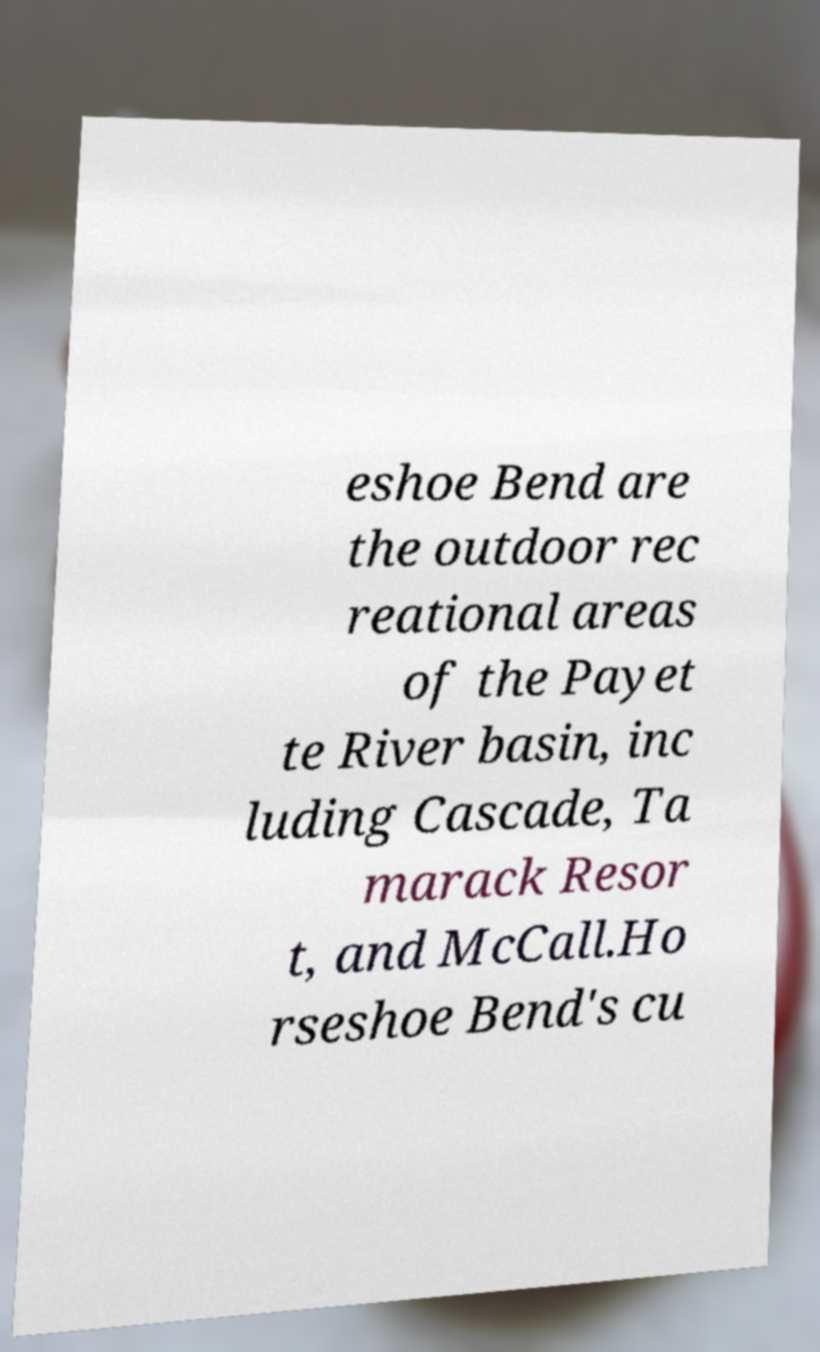For documentation purposes, I need the text within this image transcribed. Could you provide that? eshoe Bend are the outdoor rec reational areas of the Payet te River basin, inc luding Cascade, Ta marack Resor t, and McCall.Ho rseshoe Bend's cu 